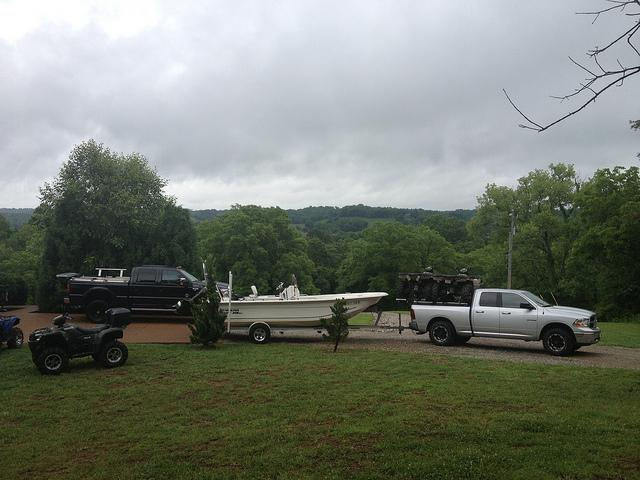What looks like it could happen any minute?

Choices:
A) tornado
B) sunshine
C) rain
D) fireworks rain 